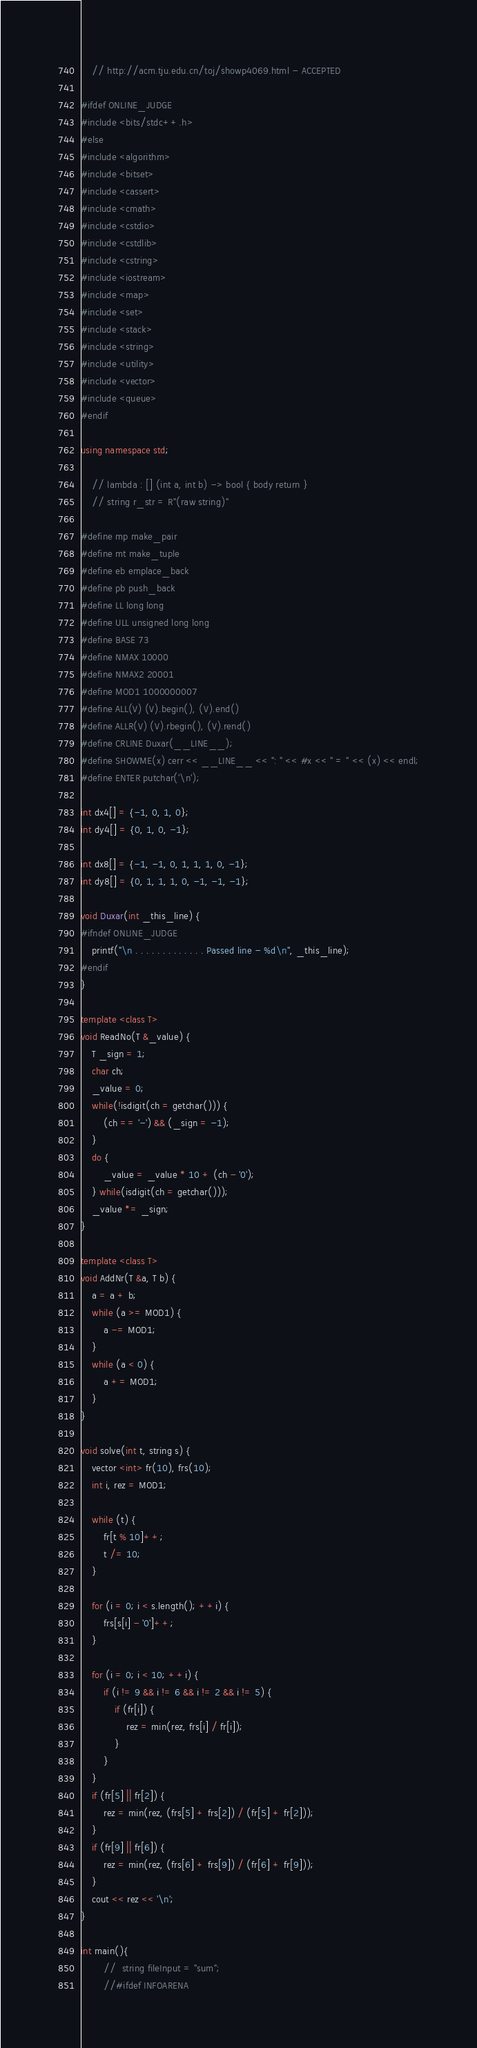<code> <loc_0><loc_0><loc_500><loc_500><_C++_>	// http://acm.tju.edu.cn/toj/showp4069.html - ACCEPTED

#ifdef ONLINE_JUDGE
#include <bits/stdc++.h>
#else
#include <algorithm>
#include <bitset>
#include <cassert>
#include <cmath>
#include <cstdio>
#include <cstdlib>
#include <cstring>
#include <iostream>
#include <map>
#include <set>
#include <stack>
#include <string>
#include <utility>
#include <vector>
#include <queue>
#endif

using namespace std;

	// lambda : [] (int a, int b) -> bool { body return }
	// string r_str = R"(raw string)"

#define mp make_pair
#define mt make_tuple
#define eb emplace_back
#define pb push_back
#define LL long long
#define ULL unsigned long long
#define BASE 73
#define NMAX 10000
#define NMAX2 20001
#define MOD1 1000000007
#define ALL(V) (V).begin(), (V).end()
#define ALLR(V) (V).rbegin(), (V).rend()
#define CRLINE Duxar(__LINE__);
#define SHOWME(x) cerr << __LINE__ << ": " << #x << " = " << (x) << endl;
#define ENTER putchar('\n');

int dx4[] = {-1, 0, 1, 0};
int dy4[] = {0, 1, 0, -1};

int dx8[] = {-1, -1, 0, 1, 1, 1, 0, -1};
int dy8[] = {0, 1, 1, 1, 0, -1, -1, -1};

void Duxar(int _this_line) {
#ifndef ONLINE_JUDGE
	printf("\n . . . . . . . . . . . . . Passed line - %d\n", _this_line);
#endif
}

template <class T>
void ReadNo(T &_value) {
	T _sign = 1;
	char ch;
	_value = 0;
	while(!isdigit(ch = getchar())) {
		(ch == '-') && (_sign = -1);
	}
	do {
		_value = _value * 10 + (ch - '0');
	} while(isdigit(ch = getchar()));
	_value *= _sign;
}

template <class T>
void AddNr(T &a, T b) {
	a = a + b;
	while (a >= MOD1) {
		a -= MOD1;
	}
	while (a < 0) {
		a += MOD1;
	}
}

void solve(int t, string s) {
	vector <int> fr(10), frs(10);
	int i, rez = MOD1;

	while (t) {
		fr[t % 10]++;
		t /= 10;
	}

	for (i = 0; i < s.length(); ++i) {
		frs[s[i] - '0']++;
	}

	for (i = 0; i < 10; ++i) {
		if (i != 9 && i != 6 && i != 2 && i != 5) {
			if (fr[i]) {
				rez = min(rez, frs[i] / fr[i]);
			}
		}
	}
	if (fr[5] || fr[2]) {
		rez = min(rez, (frs[5] + frs[2]) / (fr[5] + fr[2]));
	}
	if (fr[9] || fr[6]) {
		rez = min(rez, (frs[6] + frs[9]) / (fr[6] + fr[9]));
	}
	cout << rez << '\n';
}

int main(){
		//	string fileInput = "sum";
		//#ifdef INFOARENA</code> 